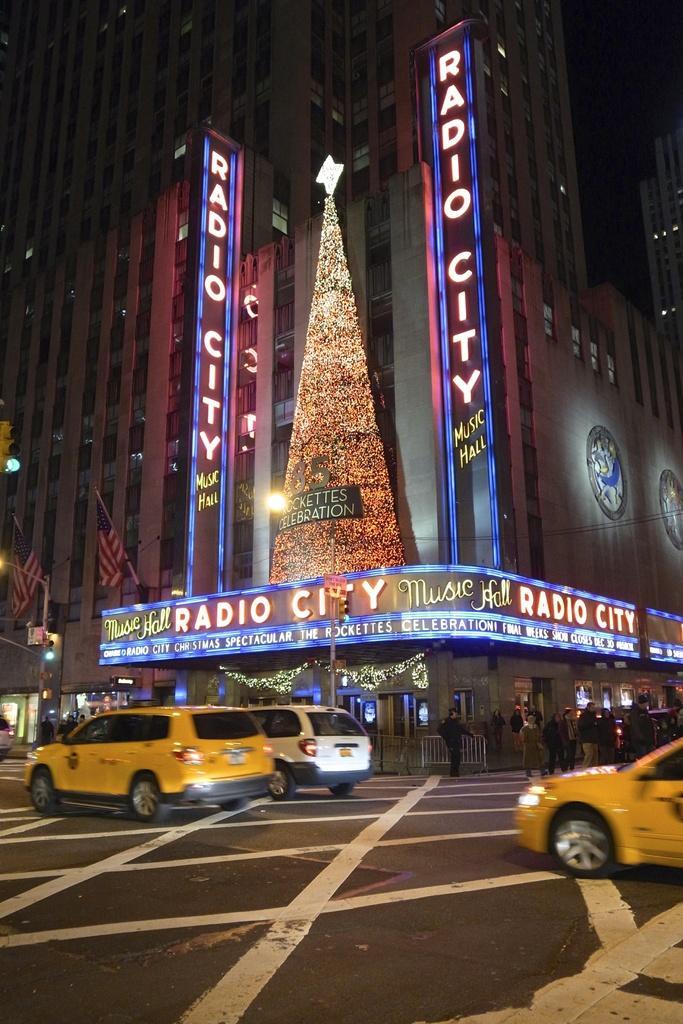In one or two sentences, can you explain what this image depicts? This is an image clicked in the dark. Here I can see few cars on the road. In the background there is a building and few boards with some text. There are many lights. 